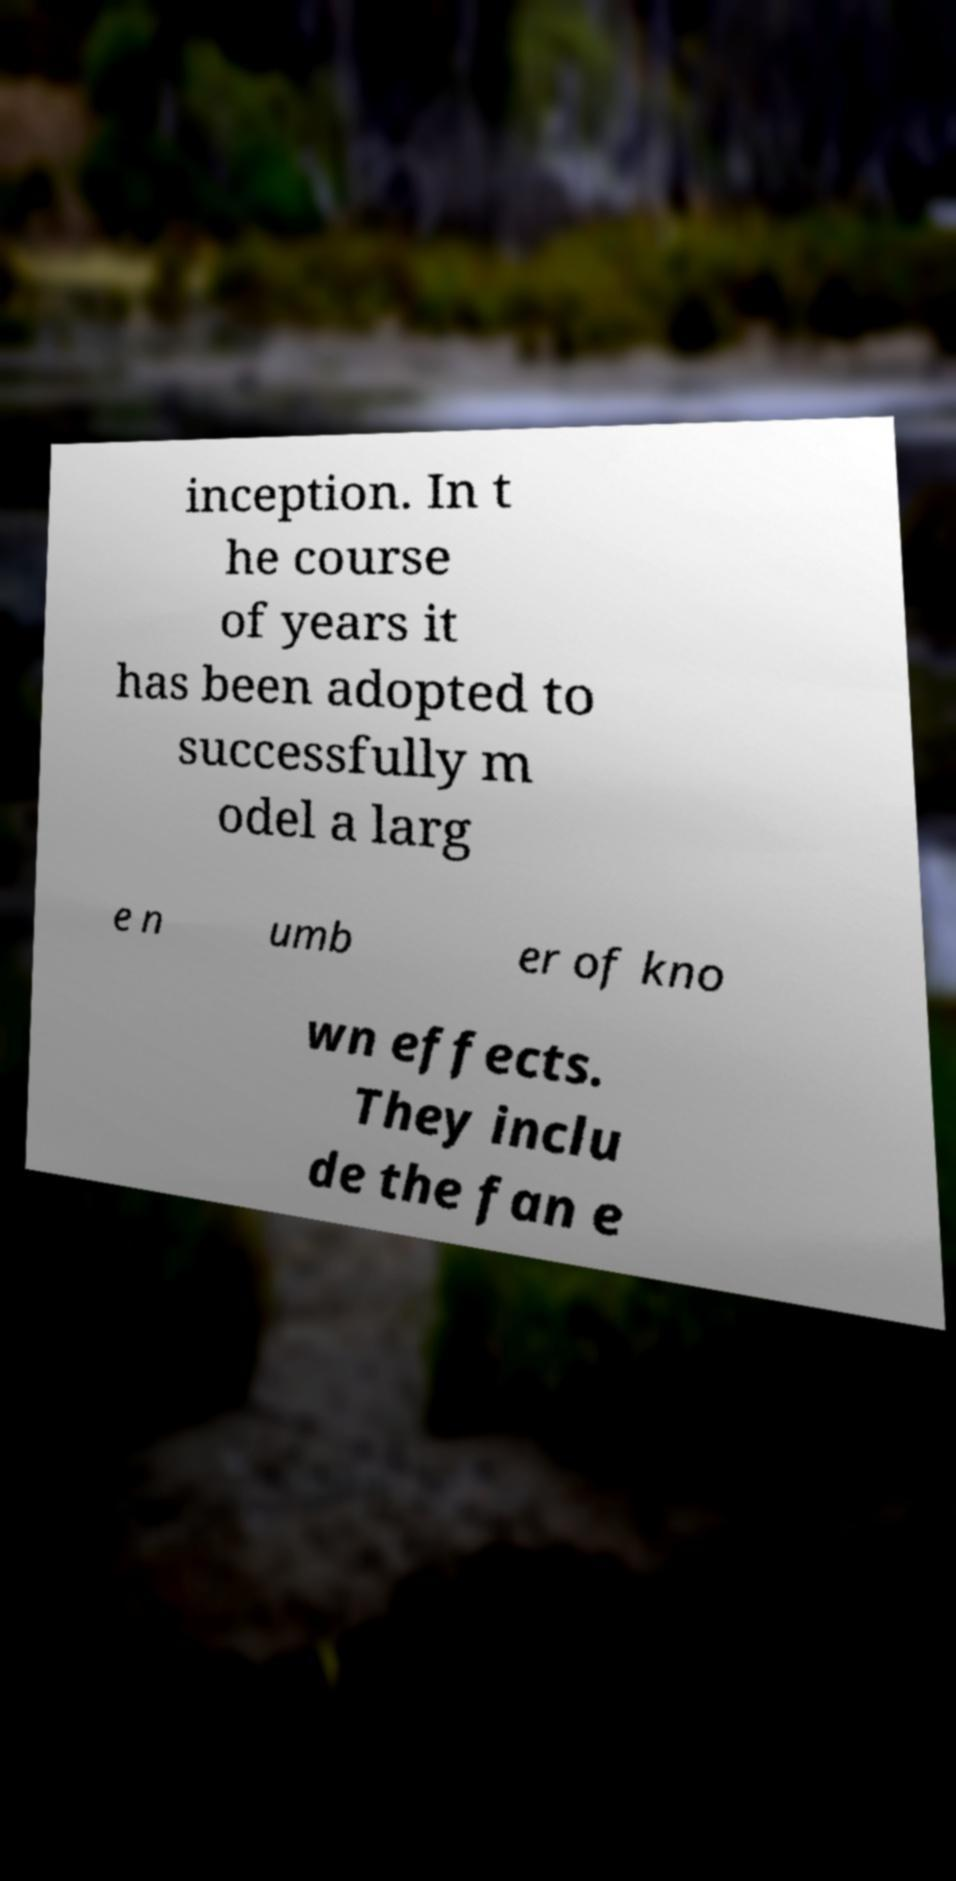Please read and relay the text visible in this image. What does it say? inception. In t he course of years it has been adopted to successfully m odel a larg e n umb er of kno wn effects. They inclu de the fan e 